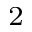Convert formula to latex. <formula><loc_0><loc_0><loc_500><loc_500>_ { 2 }</formula> 